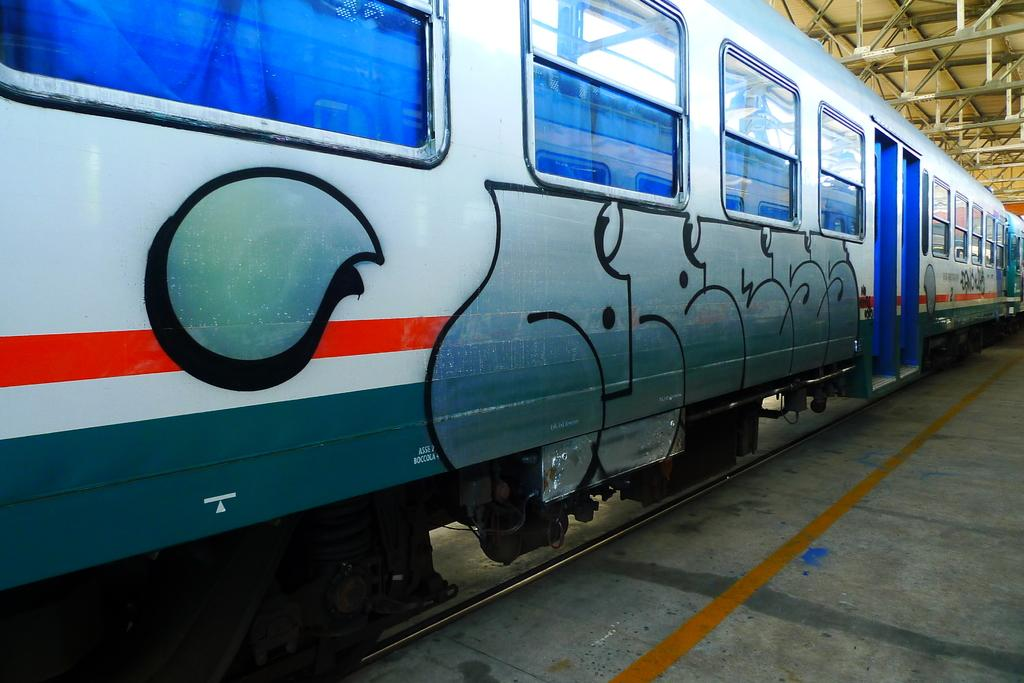What is the main subject of the image? The main subject of the image is a train. Can you describe the train's position in the image? The train is on a track. Does the train have any unique features? Yes, the train has a design. What can be seen in the background of the image? There is a roof and other objects visible in the background of the image. How many tomatoes are on the train in the image? There are no tomatoes present on the train in the image. 